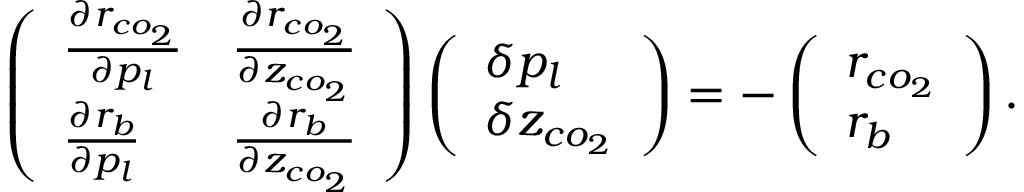<formula> <loc_0><loc_0><loc_500><loc_500>\left ( \begin{array} { l l } { \frac { \partial r _ { c o _ { 2 } } } { \partial p _ { l } } } & { \frac { \partial r _ { c o _ { 2 } } } { \partial z _ { c o _ { 2 } } } } \\ { \frac { \partial r _ { b } } { \partial p _ { l } } } & { \frac { \partial r _ { b } } { \partial z _ { c o _ { 2 } } } } \end{array} \right ) \left ( \begin{array} { l } { \delta p _ { l } } \\ { \delta z _ { c o _ { 2 } } } \end{array} \right ) = - \left ( \begin{array} { l } { r _ { c o _ { 2 } } } \\ { r _ { b } } \end{array} \right ) .</formula> 